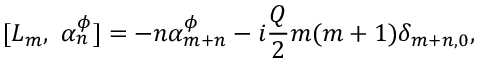Convert formula to latex. <formula><loc_0><loc_0><loc_500><loc_500>[ L _ { m } , \alpha _ { n } ^ { \phi } ] = - n \alpha _ { m + n } ^ { \phi } - i { \frac { Q } { 2 } } m ( m + 1 ) \delta _ { m + n , 0 } ,</formula> 